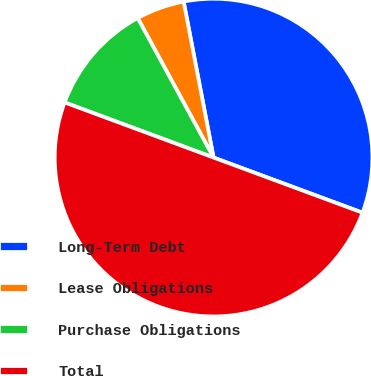<chart> <loc_0><loc_0><loc_500><loc_500><pie_chart><fcel>Long-Term Debt<fcel>Lease Obligations<fcel>Purchase Obligations<fcel>Total<nl><fcel>33.66%<fcel>4.91%<fcel>11.43%<fcel>50.0%<nl></chart> 